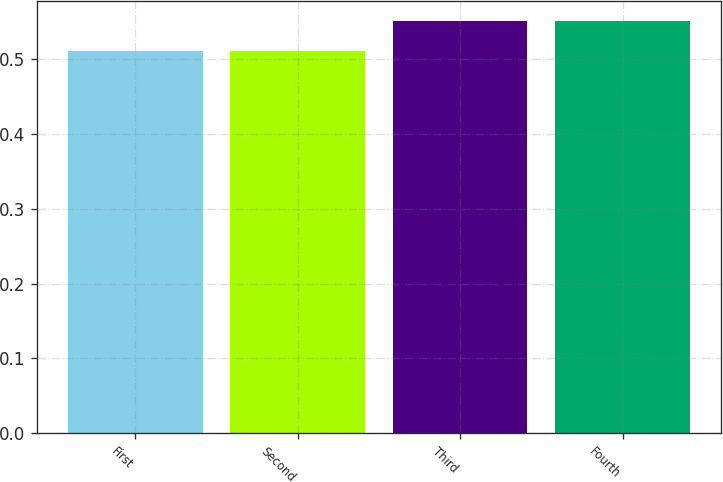Convert chart. <chart><loc_0><loc_0><loc_500><loc_500><bar_chart><fcel>First<fcel>Second<fcel>Third<fcel>Fourth<nl><fcel>0.51<fcel>0.51<fcel>0.55<fcel>0.55<nl></chart> 